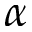Convert formula to latex. <formula><loc_0><loc_0><loc_500><loc_500>\alpha</formula> 